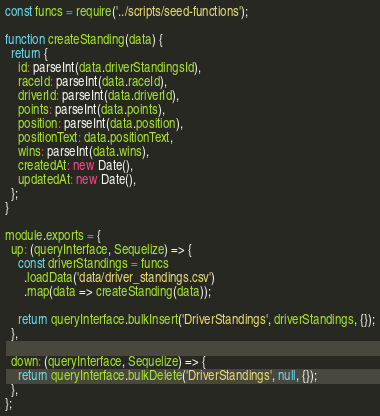Convert code to text. <code><loc_0><loc_0><loc_500><loc_500><_JavaScript_>const funcs = require('../scripts/seed-functions');

function createStanding(data) {
  return {
    id: parseInt(data.driverStandingsId),
    raceId: parseInt(data.raceId),
    driverId: parseInt(data.driverId),
    points: parseInt(data.points),
    position: parseInt(data.position),
    positionText: data.positionText,
    wins: parseInt(data.wins),
    createdAt: new Date(),
    updatedAt: new Date(),
  };
}

module.exports = {
  up: (queryInterface, Sequelize) => {
    const driverStandings = funcs
      .loadData('data/driver_standings.csv')
      .map(data => createStanding(data));

    return queryInterface.bulkInsert('DriverStandings', driverStandings, {});
  },

  down: (queryInterface, Sequelize) => {
    return queryInterface.bulkDelete('DriverStandings', null, {});
  },
};
</code> 